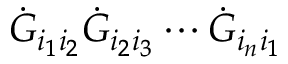<formula> <loc_0><loc_0><loc_500><loc_500>\dot { G } _ { i _ { 1 } i _ { 2 } } \dot { G } _ { i _ { 2 } i _ { 3 } } \cdots \dot { G } _ { i _ { n } i _ { 1 } }</formula> 